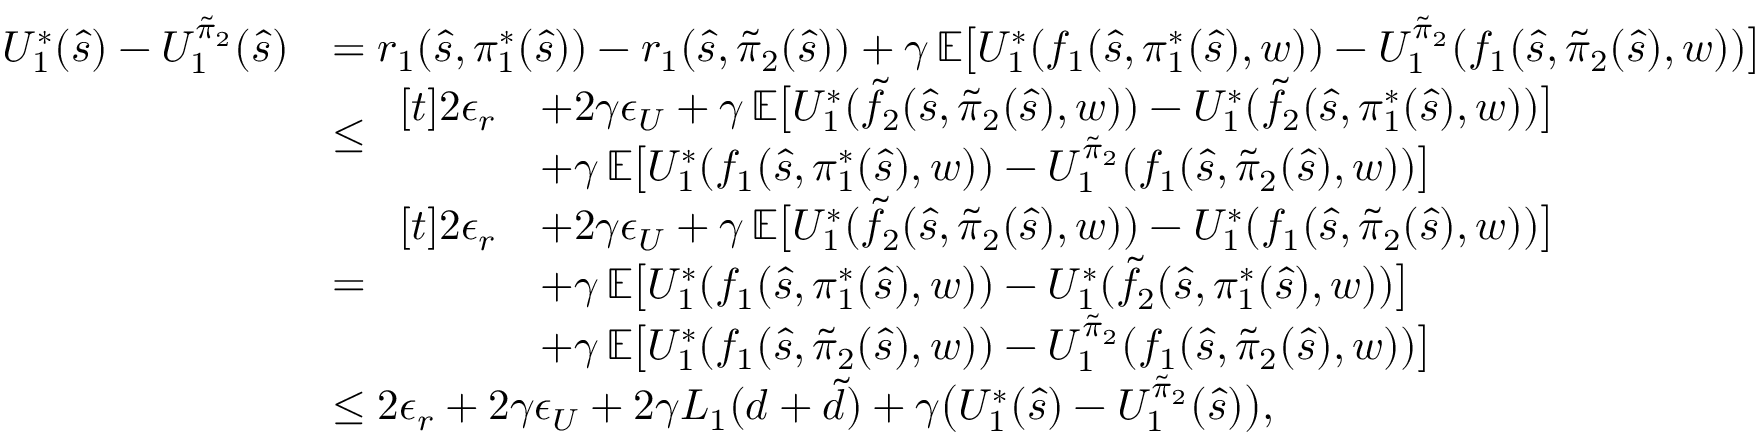Convert formula to latex. <formula><loc_0><loc_0><loc_500><loc_500>\begin{array} { r l } { U _ { 1 } ^ { * } ( \hat { s } ) - U _ { 1 } ^ { \tilde { \pi } _ { 2 } } ( \hat { s } ) } & { = r _ { 1 } ( \hat { s } , \pi _ { 1 } ^ { * } ( \hat { s } ) ) - r _ { 1 } ( \hat { s } , \tilde { \pi } _ { 2 } ( \hat { s } ) ) + \gamma \, \mathbb { E } \left [ U _ { 1 } ^ { * } ( f _ { 1 } ( \hat { s } , \pi _ { 1 } ^ { * } ( \hat { s } ) , w ) ) - U _ { 1 } ^ { \tilde { \pi } _ { 2 } } ( f _ { 1 } ( \hat { s } , \tilde { \pi } _ { 2 } ( \hat { s } ) , w ) ) \right ] } \\ & { \leq \begin{array} { r l } { [ t ] 2 \epsilon _ { r } } & { + 2 \gamma \epsilon _ { U } + \gamma \, \mathbb { E } \left [ U _ { 1 } ^ { * } ( \tilde { f } _ { 2 } ( \hat { s } , \tilde { \pi } _ { 2 } ( \hat { s } ) , w ) ) - U _ { 1 } ^ { * } ( \tilde { f } _ { 2 } ( \hat { s } , \pi _ { 1 } ^ { * } ( \hat { s } ) , w ) ) \right ] } \\ & { + \gamma \, \mathbb { E } \left [ U _ { 1 } ^ { * } ( f _ { 1 } ( \hat { s } , \pi _ { 1 } ^ { * } ( \hat { s } ) , w ) ) - U _ { 1 } ^ { \tilde { \pi } _ { 2 } } ( f _ { 1 } ( \hat { s } , \tilde { \pi } _ { 2 } ( \hat { s } ) , w ) ) \right ] } \end{array} } \\ & { = \begin{array} { r l } { [ t ] 2 \epsilon _ { r } } & { + 2 \gamma \epsilon _ { U } + \gamma \, \mathbb { E } \left [ U _ { 1 } ^ { * } ( \tilde { f } _ { 2 } ( \hat { s } , \tilde { \pi } _ { 2 } ( \hat { s } ) , w ) ) - U _ { 1 } ^ { * } ( f _ { 1 } ( \hat { s } , \tilde { \pi } _ { 2 } ( \hat { s } ) , w ) ) \right ] } \\ & { + \gamma \, \mathbb { E } \left [ U _ { 1 } ^ { * } ( f _ { 1 } ( \hat { s } , \pi _ { 1 } ^ { * } ( \hat { s } ) , w ) ) - U _ { 1 } ^ { * } ( \tilde { f } _ { 2 } ( \hat { s } , \pi _ { 1 } ^ { * } ( \hat { s } ) , w ) ) \right ] } \\ & { + \gamma \, \mathbb { E } \left [ U _ { 1 } ^ { * } ( f _ { 1 } ( \hat { s } , \tilde { \pi } _ { 2 } ( \hat { s } ) , w ) ) - U _ { 1 } ^ { \tilde { \pi } _ { 2 } } ( f _ { 1 } ( \hat { s } , \tilde { \pi } _ { 2 } ( \hat { s } ) , w ) ) \right ] } \end{array} } \\ & { \leq 2 \epsilon _ { r } + 2 \gamma \epsilon _ { U } + 2 \gamma L _ { 1 } ( d + \tilde { d } ) + \gamma \left ( U _ { 1 } ^ { * } ( \hat { s } ) - U _ { 1 } ^ { \tilde { \pi } _ { 2 } } ( \hat { s } ) \right ) , } \end{array}</formula> 